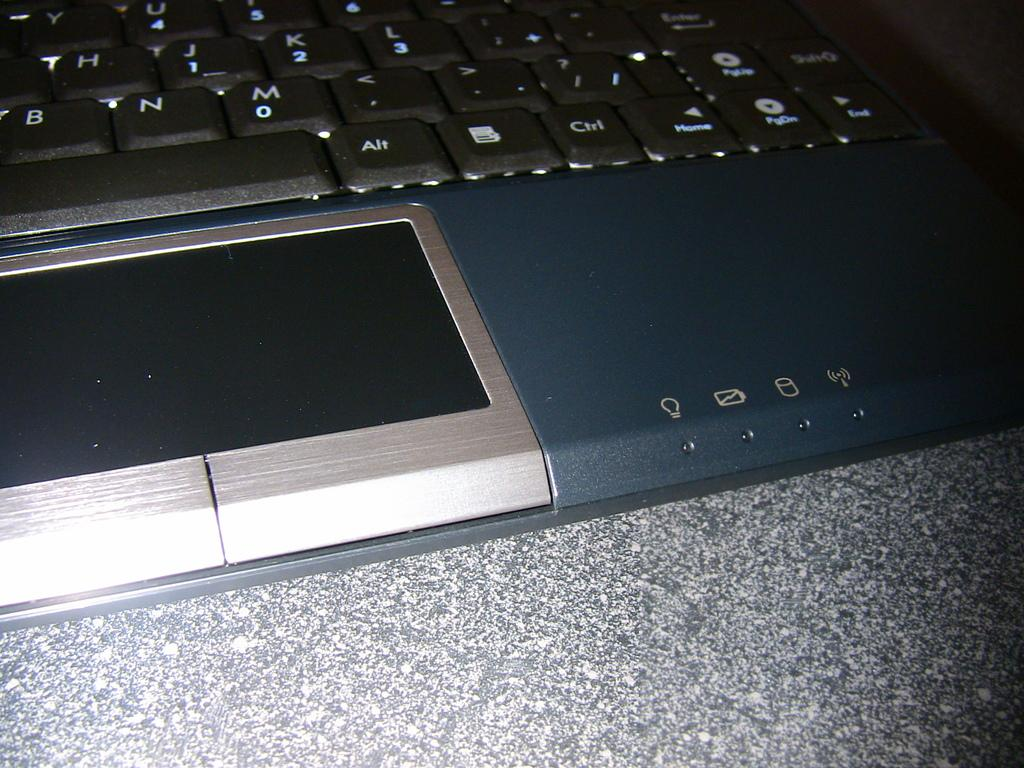Provide a one-sentence caption for the provided image. A laptop is shown with the Alt and Ctrl keys displayed at the bottom. 